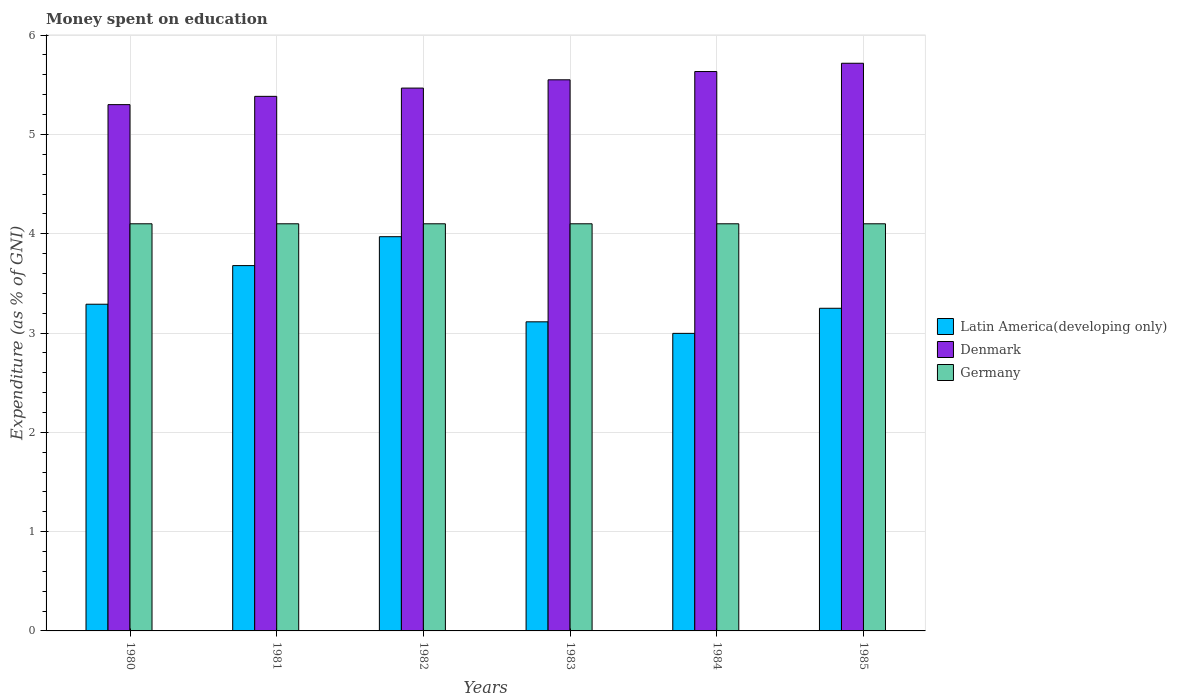How many groups of bars are there?
Offer a terse response. 6. Are the number of bars per tick equal to the number of legend labels?
Offer a terse response. Yes. Are the number of bars on each tick of the X-axis equal?
Make the answer very short. Yes. How many bars are there on the 5th tick from the left?
Your answer should be compact. 3. What is the label of the 1st group of bars from the left?
Offer a very short reply. 1980. What is the amount of money spent on education in Denmark in 1985?
Offer a terse response. 5.72. Across all years, what is the maximum amount of money spent on education in Germany?
Offer a very short reply. 4.1. Across all years, what is the minimum amount of money spent on education in Latin America(developing only)?
Your answer should be very brief. 3. In which year was the amount of money spent on education in Latin America(developing only) minimum?
Your response must be concise. 1984. What is the total amount of money spent on education in Latin America(developing only) in the graph?
Provide a succinct answer. 20.3. What is the difference between the amount of money spent on education in Denmark in 1981 and the amount of money spent on education in Germany in 1983?
Keep it short and to the point. 1.28. What is the average amount of money spent on education in Denmark per year?
Offer a terse response. 5.51. In the year 1984, what is the difference between the amount of money spent on education in Denmark and amount of money spent on education in Latin America(developing only)?
Your answer should be compact. 2.64. What is the ratio of the amount of money spent on education in Denmark in 1981 to that in 1984?
Keep it short and to the point. 0.96. Is the difference between the amount of money spent on education in Denmark in 1980 and 1985 greater than the difference between the amount of money spent on education in Latin America(developing only) in 1980 and 1985?
Your answer should be very brief. No. What is the difference between the highest and the second highest amount of money spent on education in Latin America(developing only)?
Offer a very short reply. 0.29. What does the 1st bar from the left in 1984 represents?
Make the answer very short. Latin America(developing only). Is it the case that in every year, the sum of the amount of money spent on education in Denmark and amount of money spent on education in Germany is greater than the amount of money spent on education in Latin America(developing only)?
Make the answer very short. Yes. How many bars are there?
Offer a terse response. 18. How many years are there in the graph?
Your answer should be compact. 6. What is the difference between two consecutive major ticks on the Y-axis?
Provide a succinct answer. 1. Does the graph contain grids?
Your response must be concise. Yes. How many legend labels are there?
Provide a succinct answer. 3. How are the legend labels stacked?
Your answer should be compact. Vertical. What is the title of the graph?
Offer a very short reply. Money spent on education. What is the label or title of the X-axis?
Your response must be concise. Years. What is the label or title of the Y-axis?
Give a very brief answer. Expenditure (as % of GNI). What is the Expenditure (as % of GNI) of Latin America(developing only) in 1980?
Your answer should be very brief. 3.29. What is the Expenditure (as % of GNI) of Denmark in 1980?
Your answer should be compact. 5.3. What is the Expenditure (as % of GNI) in Germany in 1980?
Your response must be concise. 4.1. What is the Expenditure (as % of GNI) in Latin America(developing only) in 1981?
Your answer should be very brief. 3.68. What is the Expenditure (as % of GNI) in Denmark in 1981?
Provide a short and direct response. 5.38. What is the Expenditure (as % of GNI) in Germany in 1981?
Your answer should be compact. 4.1. What is the Expenditure (as % of GNI) of Latin America(developing only) in 1982?
Offer a very short reply. 3.97. What is the Expenditure (as % of GNI) in Denmark in 1982?
Your response must be concise. 5.47. What is the Expenditure (as % of GNI) of Germany in 1982?
Ensure brevity in your answer.  4.1. What is the Expenditure (as % of GNI) of Latin America(developing only) in 1983?
Your response must be concise. 3.11. What is the Expenditure (as % of GNI) in Denmark in 1983?
Keep it short and to the point. 5.55. What is the Expenditure (as % of GNI) of Germany in 1983?
Your answer should be very brief. 4.1. What is the Expenditure (as % of GNI) of Latin America(developing only) in 1984?
Keep it short and to the point. 3. What is the Expenditure (as % of GNI) in Denmark in 1984?
Give a very brief answer. 5.63. What is the Expenditure (as % of GNI) of Germany in 1984?
Your answer should be very brief. 4.1. What is the Expenditure (as % of GNI) of Latin America(developing only) in 1985?
Your response must be concise. 3.25. What is the Expenditure (as % of GNI) of Denmark in 1985?
Provide a short and direct response. 5.72. What is the Expenditure (as % of GNI) in Germany in 1985?
Give a very brief answer. 4.1. Across all years, what is the maximum Expenditure (as % of GNI) of Latin America(developing only)?
Keep it short and to the point. 3.97. Across all years, what is the maximum Expenditure (as % of GNI) of Denmark?
Provide a short and direct response. 5.72. Across all years, what is the minimum Expenditure (as % of GNI) in Latin America(developing only)?
Your answer should be very brief. 3. What is the total Expenditure (as % of GNI) in Latin America(developing only) in the graph?
Offer a very short reply. 20.3. What is the total Expenditure (as % of GNI) of Denmark in the graph?
Offer a terse response. 33.05. What is the total Expenditure (as % of GNI) in Germany in the graph?
Offer a terse response. 24.6. What is the difference between the Expenditure (as % of GNI) of Latin America(developing only) in 1980 and that in 1981?
Ensure brevity in your answer.  -0.39. What is the difference between the Expenditure (as % of GNI) of Denmark in 1980 and that in 1981?
Provide a short and direct response. -0.08. What is the difference between the Expenditure (as % of GNI) in Germany in 1980 and that in 1981?
Ensure brevity in your answer.  0. What is the difference between the Expenditure (as % of GNI) of Latin America(developing only) in 1980 and that in 1982?
Make the answer very short. -0.68. What is the difference between the Expenditure (as % of GNI) of Latin America(developing only) in 1980 and that in 1983?
Your answer should be very brief. 0.18. What is the difference between the Expenditure (as % of GNI) of Latin America(developing only) in 1980 and that in 1984?
Your response must be concise. 0.29. What is the difference between the Expenditure (as % of GNI) in Germany in 1980 and that in 1984?
Ensure brevity in your answer.  0. What is the difference between the Expenditure (as % of GNI) in Latin America(developing only) in 1980 and that in 1985?
Your answer should be compact. 0.04. What is the difference between the Expenditure (as % of GNI) of Denmark in 1980 and that in 1985?
Provide a short and direct response. -0.42. What is the difference between the Expenditure (as % of GNI) in Germany in 1980 and that in 1985?
Ensure brevity in your answer.  0. What is the difference between the Expenditure (as % of GNI) in Latin America(developing only) in 1981 and that in 1982?
Offer a very short reply. -0.29. What is the difference between the Expenditure (as % of GNI) in Denmark in 1981 and that in 1982?
Your response must be concise. -0.08. What is the difference between the Expenditure (as % of GNI) in Latin America(developing only) in 1981 and that in 1983?
Provide a succinct answer. 0.57. What is the difference between the Expenditure (as % of GNI) in Latin America(developing only) in 1981 and that in 1984?
Offer a terse response. 0.68. What is the difference between the Expenditure (as % of GNI) in Denmark in 1981 and that in 1984?
Your answer should be compact. -0.25. What is the difference between the Expenditure (as % of GNI) in Germany in 1981 and that in 1984?
Your answer should be very brief. 0. What is the difference between the Expenditure (as % of GNI) in Latin America(developing only) in 1981 and that in 1985?
Your answer should be compact. 0.43. What is the difference between the Expenditure (as % of GNI) in Denmark in 1981 and that in 1985?
Your answer should be compact. -0.33. What is the difference between the Expenditure (as % of GNI) of Germany in 1981 and that in 1985?
Your answer should be very brief. 0. What is the difference between the Expenditure (as % of GNI) in Latin America(developing only) in 1982 and that in 1983?
Provide a short and direct response. 0.86. What is the difference between the Expenditure (as % of GNI) of Denmark in 1982 and that in 1983?
Your answer should be compact. -0.08. What is the difference between the Expenditure (as % of GNI) of Germany in 1982 and that in 1983?
Provide a short and direct response. 0. What is the difference between the Expenditure (as % of GNI) of Latin America(developing only) in 1982 and that in 1984?
Ensure brevity in your answer.  0.97. What is the difference between the Expenditure (as % of GNI) in Denmark in 1982 and that in 1984?
Offer a terse response. -0.17. What is the difference between the Expenditure (as % of GNI) in Germany in 1982 and that in 1984?
Keep it short and to the point. 0. What is the difference between the Expenditure (as % of GNI) in Latin America(developing only) in 1982 and that in 1985?
Provide a short and direct response. 0.72. What is the difference between the Expenditure (as % of GNI) of Germany in 1982 and that in 1985?
Provide a short and direct response. 0. What is the difference between the Expenditure (as % of GNI) of Latin America(developing only) in 1983 and that in 1984?
Your answer should be very brief. 0.12. What is the difference between the Expenditure (as % of GNI) in Denmark in 1983 and that in 1984?
Make the answer very short. -0.08. What is the difference between the Expenditure (as % of GNI) in Germany in 1983 and that in 1984?
Keep it short and to the point. 0. What is the difference between the Expenditure (as % of GNI) of Latin America(developing only) in 1983 and that in 1985?
Offer a very short reply. -0.14. What is the difference between the Expenditure (as % of GNI) in Denmark in 1983 and that in 1985?
Ensure brevity in your answer.  -0.17. What is the difference between the Expenditure (as % of GNI) in Latin America(developing only) in 1984 and that in 1985?
Ensure brevity in your answer.  -0.25. What is the difference between the Expenditure (as % of GNI) in Denmark in 1984 and that in 1985?
Keep it short and to the point. -0.08. What is the difference between the Expenditure (as % of GNI) in Germany in 1984 and that in 1985?
Ensure brevity in your answer.  0. What is the difference between the Expenditure (as % of GNI) of Latin America(developing only) in 1980 and the Expenditure (as % of GNI) of Denmark in 1981?
Your answer should be compact. -2.09. What is the difference between the Expenditure (as % of GNI) of Latin America(developing only) in 1980 and the Expenditure (as % of GNI) of Germany in 1981?
Your answer should be very brief. -0.81. What is the difference between the Expenditure (as % of GNI) in Latin America(developing only) in 1980 and the Expenditure (as % of GNI) in Denmark in 1982?
Your response must be concise. -2.18. What is the difference between the Expenditure (as % of GNI) in Latin America(developing only) in 1980 and the Expenditure (as % of GNI) in Germany in 1982?
Your answer should be compact. -0.81. What is the difference between the Expenditure (as % of GNI) of Denmark in 1980 and the Expenditure (as % of GNI) of Germany in 1982?
Ensure brevity in your answer.  1.2. What is the difference between the Expenditure (as % of GNI) in Latin America(developing only) in 1980 and the Expenditure (as % of GNI) in Denmark in 1983?
Ensure brevity in your answer.  -2.26. What is the difference between the Expenditure (as % of GNI) in Latin America(developing only) in 1980 and the Expenditure (as % of GNI) in Germany in 1983?
Offer a very short reply. -0.81. What is the difference between the Expenditure (as % of GNI) in Denmark in 1980 and the Expenditure (as % of GNI) in Germany in 1983?
Your answer should be very brief. 1.2. What is the difference between the Expenditure (as % of GNI) in Latin America(developing only) in 1980 and the Expenditure (as % of GNI) in Denmark in 1984?
Ensure brevity in your answer.  -2.34. What is the difference between the Expenditure (as % of GNI) in Latin America(developing only) in 1980 and the Expenditure (as % of GNI) in Germany in 1984?
Offer a very short reply. -0.81. What is the difference between the Expenditure (as % of GNI) in Latin America(developing only) in 1980 and the Expenditure (as % of GNI) in Denmark in 1985?
Make the answer very short. -2.43. What is the difference between the Expenditure (as % of GNI) of Latin America(developing only) in 1980 and the Expenditure (as % of GNI) of Germany in 1985?
Make the answer very short. -0.81. What is the difference between the Expenditure (as % of GNI) in Denmark in 1980 and the Expenditure (as % of GNI) in Germany in 1985?
Keep it short and to the point. 1.2. What is the difference between the Expenditure (as % of GNI) of Latin America(developing only) in 1981 and the Expenditure (as % of GNI) of Denmark in 1982?
Your response must be concise. -1.79. What is the difference between the Expenditure (as % of GNI) of Latin America(developing only) in 1981 and the Expenditure (as % of GNI) of Germany in 1982?
Provide a succinct answer. -0.42. What is the difference between the Expenditure (as % of GNI) of Denmark in 1981 and the Expenditure (as % of GNI) of Germany in 1982?
Your response must be concise. 1.28. What is the difference between the Expenditure (as % of GNI) in Latin America(developing only) in 1981 and the Expenditure (as % of GNI) in Denmark in 1983?
Offer a terse response. -1.87. What is the difference between the Expenditure (as % of GNI) in Latin America(developing only) in 1981 and the Expenditure (as % of GNI) in Germany in 1983?
Your response must be concise. -0.42. What is the difference between the Expenditure (as % of GNI) in Denmark in 1981 and the Expenditure (as % of GNI) in Germany in 1983?
Give a very brief answer. 1.28. What is the difference between the Expenditure (as % of GNI) of Latin America(developing only) in 1981 and the Expenditure (as % of GNI) of Denmark in 1984?
Offer a very short reply. -1.95. What is the difference between the Expenditure (as % of GNI) in Latin America(developing only) in 1981 and the Expenditure (as % of GNI) in Germany in 1984?
Ensure brevity in your answer.  -0.42. What is the difference between the Expenditure (as % of GNI) in Denmark in 1981 and the Expenditure (as % of GNI) in Germany in 1984?
Offer a very short reply. 1.28. What is the difference between the Expenditure (as % of GNI) of Latin America(developing only) in 1981 and the Expenditure (as % of GNI) of Denmark in 1985?
Your answer should be very brief. -2.04. What is the difference between the Expenditure (as % of GNI) of Latin America(developing only) in 1981 and the Expenditure (as % of GNI) of Germany in 1985?
Provide a succinct answer. -0.42. What is the difference between the Expenditure (as % of GNI) in Denmark in 1981 and the Expenditure (as % of GNI) in Germany in 1985?
Provide a succinct answer. 1.28. What is the difference between the Expenditure (as % of GNI) in Latin America(developing only) in 1982 and the Expenditure (as % of GNI) in Denmark in 1983?
Your response must be concise. -1.58. What is the difference between the Expenditure (as % of GNI) in Latin America(developing only) in 1982 and the Expenditure (as % of GNI) in Germany in 1983?
Keep it short and to the point. -0.13. What is the difference between the Expenditure (as % of GNI) in Denmark in 1982 and the Expenditure (as % of GNI) in Germany in 1983?
Give a very brief answer. 1.37. What is the difference between the Expenditure (as % of GNI) in Latin America(developing only) in 1982 and the Expenditure (as % of GNI) in Denmark in 1984?
Your response must be concise. -1.66. What is the difference between the Expenditure (as % of GNI) in Latin America(developing only) in 1982 and the Expenditure (as % of GNI) in Germany in 1984?
Keep it short and to the point. -0.13. What is the difference between the Expenditure (as % of GNI) in Denmark in 1982 and the Expenditure (as % of GNI) in Germany in 1984?
Offer a very short reply. 1.37. What is the difference between the Expenditure (as % of GNI) in Latin America(developing only) in 1982 and the Expenditure (as % of GNI) in Denmark in 1985?
Keep it short and to the point. -1.75. What is the difference between the Expenditure (as % of GNI) in Latin America(developing only) in 1982 and the Expenditure (as % of GNI) in Germany in 1985?
Ensure brevity in your answer.  -0.13. What is the difference between the Expenditure (as % of GNI) in Denmark in 1982 and the Expenditure (as % of GNI) in Germany in 1985?
Provide a short and direct response. 1.37. What is the difference between the Expenditure (as % of GNI) in Latin America(developing only) in 1983 and the Expenditure (as % of GNI) in Denmark in 1984?
Make the answer very short. -2.52. What is the difference between the Expenditure (as % of GNI) of Latin America(developing only) in 1983 and the Expenditure (as % of GNI) of Germany in 1984?
Give a very brief answer. -0.99. What is the difference between the Expenditure (as % of GNI) of Denmark in 1983 and the Expenditure (as % of GNI) of Germany in 1984?
Keep it short and to the point. 1.45. What is the difference between the Expenditure (as % of GNI) of Latin America(developing only) in 1983 and the Expenditure (as % of GNI) of Denmark in 1985?
Offer a terse response. -2.6. What is the difference between the Expenditure (as % of GNI) in Latin America(developing only) in 1983 and the Expenditure (as % of GNI) in Germany in 1985?
Your answer should be very brief. -0.99. What is the difference between the Expenditure (as % of GNI) in Denmark in 1983 and the Expenditure (as % of GNI) in Germany in 1985?
Ensure brevity in your answer.  1.45. What is the difference between the Expenditure (as % of GNI) in Latin America(developing only) in 1984 and the Expenditure (as % of GNI) in Denmark in 1985?
Your answer should be very brief. -2.72. What is the difference between the Expenditure (as % of GNI) of Latin America(developing only) in 1984 and the Expenditure (as % of GNI) of Germany in 1985?
Your response must be concise. -1.1. What is the difference between the Expenditure (as % of GNI) in Denmark in 1984 and the Expenditure (as % of GNI) in Germany in 1985?
Your answer should be compact. 1.53. What is the average Expenditure (as % of GNI) of Latin America(developing only) per year?
Ensure brevity in your answer.  3.38. What is the average Expenditure (as % of GNI) of Denmark per year?
Your answer should be very brief. 5.51. What is the average Expenditure (as % of GNI) of Germany per year?
Ensure brevity in your answer.  4.1. In the year 1980, what is the difference between the Expenditure (as % of GNI) of Latin America(developing only) and Expenditure (as % of GNI) of Denmark?
Make the answer very short. -2.01. In the year 1980, what is the difference between the Expenditure (as % of GNI) in Latin America(developing only) and Expenditure (as % of GNI) in Germany?
Offer a very short reply. -0.81. In the year 1980, what is the difference between the Expenditure (as % of GNI) of Denmark and Expenditure (as % of GNI) of Germany?
Make the answer very short. 1.2. In the year 1981, what is the difference between the Expenditure (as % of GNI) of Latin America(developing only) and Expenditure (as % of GNI) of Denmark?
Provide a short and direct response. -1.7. In the year 1981, what is the difference between the Expenditure (as % of GNI) of Latin America(developing only) and Expenditure (as % of GNI) of Germany?
Your answer should be very brief. -0.42. In the year 1981, what is the difference between the Expenditure (as % of GNI) of Denmark and Expenditure (as % of GNI) of Germany?
Your answer should be very brief. 1.28. In the year 1982, what is the difference between the Expenditure (as % of GNI) of Latin America(developing only) and Expenditure (as % of GNI) of Denmark?
Keep it short and to the point. -1.5. In the year 1982, what is the difference between the Expenditure (as % of GNI) of Latin America(developing only) and Expenditure (as % of GNI) of Germany?
Offer a terse response. -0.13. In the year 1982, what is the difference between the Expenditure (as % of GNI) of Denmark and Expenditure (as % of GNI) of Germany?
Your answer should be compact. 1.37. In the year 1983, what is the difference between the Expenditure (as % of GNI) of Latin America(developing only) and Expenditure (as % of GNI) of Denmark?
Keep it short and to the point. -2.44. In the year 1983, what is the difference between the Expenditure (as % of GNI) of Latin America(developing only) and Expenditure (as % of GNI) of Germany?
Give a very brief answer. -0.99. In the year 1983, what is the difference between the Expenditure (as % of GNI) of Denmark and Expenditure (as % of GNI) of Germany?
Provide a succinct answer. 1.45. In the year 1984, what is the difference between the Expenditure (as % of GNI) of Latin America(developing only) and Expenditure (as % of GNI) of Denmark?
Offer a terse response. -2.64. In the year 1984, what is the difference between the Expenditure (as % of GNI) in Latin America(developing only) and Expenditure (as % of GNI) in Germany?
Your answer should be very brief. -1.1. In the year 1984, what is the difference between the Expenditure (as % of GNI) of Denmark and Expenditure (as % of GNI) of Germany?
Your answer should be very brief. 1.53. In the year 1985, what is the difference between the Expenditure (as % of GNI) in Latin America(developing only) and Expenditure (as % of GNI) in Denmark?
Your answer should be very brief. -2.47. In the year 1985, what is the difference between the Expenditure (as % of GNI) in Latin America(developing only) and Expenditure (as % of GNI) in Germany?
Keep it short and to the point. -0.85. In the year 1985, what is the difference between the Expenditure (as % of GNI) of Denmark and Expenditure (as % of GNI) of Germany?
Provide a short and direct response. 1.62. What is the ratio of the Expenditure (as % of GNI) in Latin America(developing only) in 1980 to that in 1981?
Your answer should be very brief. 0.89. What is the ratio of the Expenditure (as % of GNI) in Denmark in 1980 to that in 1981?
Your answer should be very brief. 0.98. What is the ratio of the Expenditure (as % of GNI) in Germany in 1980 to that in 1981?
Ensure brevity in your answer.  1. What is the ratio of the Expenditure (as % of GNI) in Latin America(developing only) in 1980 to that in 1982?
Ensure brevity in your answer.  0.83. What is the ratio of the Expenditure (as % of GNI) of Denmark in 1980 to that in 1982?
Provide a succinct answer. 0.97. What is the ratio of the Expenditure (as % of GNI) of Germany in 1980 to that in 1982?
Your answer should be very brief. 1. What is the ratio of the Expenditure (as % of GNI) in Latin America(developing only) in 1980 to that in 1983?
Offer a very short reply. 1.06. What is the ratio of the Expenditure (as % of GNI) of Denmark in 1980 to that in 1983?
Provide a short and direct response. 0.95. What is the ratio of the Expenditure (as % of GNI) of Latin America(developing only) in 1980 to that in 1984?
Give a very brief answer. 1.1. What is the ratio of the Expenditure (as % of GNI) in Denmark in 1980 to that in 1984?
Make the answer very short. 0.94. What is the ratio of the Expenditure (as % of GNI) in Latin America(developing only) in 1980 to that in 1985?
Your answer should be very brief. 1.01. What is the ratio of the Expenditure (as % of GNI) of Denmark in 1980 to that in 1985?
Give a very brief answer. 0.93. What is the ratio of the Expenditure (as % of GNI) of Latin America(developing only) in 1981 to that in 1982?
Your answer should be very brief. 0.93. What is the ratio of the Expenditure (as % of GNI) of Germany in 1981 to that in 1982?
Make the answer very short. 1. What is the ratio of the Expenditure (as % of GNI) of Latin America(developing only) in 1981 to that in 1983?
Offer a very short reply. 1.18. What is the ratio of the Expenditure (as % of GNI) in Latin America(developing only) in 1981 to that in 1984?
Offer a terse response. 1.23. What is the ratio of the Expenditure (as % of GNI) in Denmark in 1981 to that in 1984?
Keep it short and to the point. 0.96. What is the ratio of the Expenditure (as % of GNI) in Germany in 1981 to that in 1984?
Your answer should be very brief. 1. What is the ratio of the Expenditure (as % of GNI) in Latin America(developing only) in 1981 to that in 1985?
Your answer should be very brief. 1.13. What is the ratio of the Expenditure (as % of GNI) of Denmark in 1981 to that in 1985?
Provide a succinct answer. 0.94. What is the ratio of the Expenditure (as % of GNI) of Germany in 1981 to that in 1985?
Offer a terse response. 1. What is the ratio of the Expenditure (as % of GNI) of Latin America(developing only) in 1982 to that in 1983?
Your answer should be compact. 1.28. What is the ratio of the Expenditure (as % of GNI) in Denmark in 1982 to that in 1983?
Provide a succinct answer. 0.98. What is the ratio of the Expenditure (as % of GNI) in Latin America(developing only) in 1982 to that in 1984?
Offer a very short reply. 1.32. What is the ratio of the Expenditure (as % of GNI) of Denmark in 1982 to that in 1984?
Ensure brevity in your answer.  0.97. What is the ratio of the Expenditure (as % of GNI) in Latin America(developing only) in 1982 to that in 1985?
Make the answer very short. 1.22. What is the ratio of the Expenditure (as % of GNI) of Denmark in 1982 to that in 1985?
Your response must be concise. 0.96. What is the ratio of the Expenditure (as % of GNI) in Latin America(developing only) in 1983 to that in 1984?
Ensure brevity in your answer.  1.04. What is the ratio of the Expenditure (as % of GNI) in Denmark in 1983 to that in 1984?
Provide a short and direct response. 0.99. What is the ratio of the Expenditure (as % of GNI) in Germany in 1983 to that in 1984?
Give a very brief answer. 1. What is the ratio of the Expenditure (as % of GNI) in Latin America(developing only) in 1983 to that in 1985?
Offer a terse response. 0.96. What is the ratio of the Expenditure (as % of GNI) in Denmark in 1983 to that in 1985?
Offer a terse response. 0.97. What is the ratio of the Expenditure (as % of GNI) in Latin America(developing only) in 1984 to that in 1985?
Your answer should be compact. 0.92. What is the ratio of the Expenditure (as % of GNI) in Denmark in 1984 to that in 1985?
Provide a succinct answer. 0.99. What is the ratio of the Expenditure (as % of GNI) in Germany in 1984 to that in 1985?
Your answer should be compact. 1. What is the difference between the highest and the second highest Expenditure (as % of GNI) of Latin America(developing only)?
Offer a terse response. 0.29. What is the difference between the highest and the second highest Expenditure (as % of GNI) of Denmark?
Your response must be concise. 0.08. What is the difference between the highest and the second highest Expenditure (as % of GNI) in Germany?
Keep it short and to the point. 0. What is the difference between the highest and the lowest Expenditure (as % of GNI) of Latin America(developing only)?
Your answer should be very brief. 0.97. What is the difference between the highest and the lowest Expenditure (as % of GNI) of Denmark?
Provide a short and direct response. 0.42. 